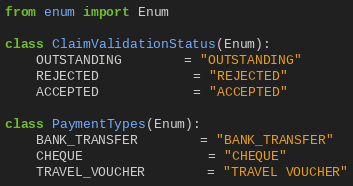Convert code to text. <code><loc_0><loc_0><loc_500><loc_500><_Python_>
from enum import Enum

class ClaimValidationStatus(Enum):
	OUTSTANDING 		= "OUTSTANDING"
	REJECTED 			= "REJECTED"
	ACCEPTED 			= "ACCEPTED"

class PaymentTypes(Enum):
	BANK_TRANSFER 		= "BANK_TRANSFER"
	CHEQUE 				= "CHEQUE"
	TRAVEL_VOUCHER		= "TRAVEL VOUCHER"

</code> 